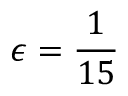Convert formula to latex. <formula><loc_0><loc_0><loc_500><loc_500>\epsilon = \frac { 1 } { 1 5 }</formula> 